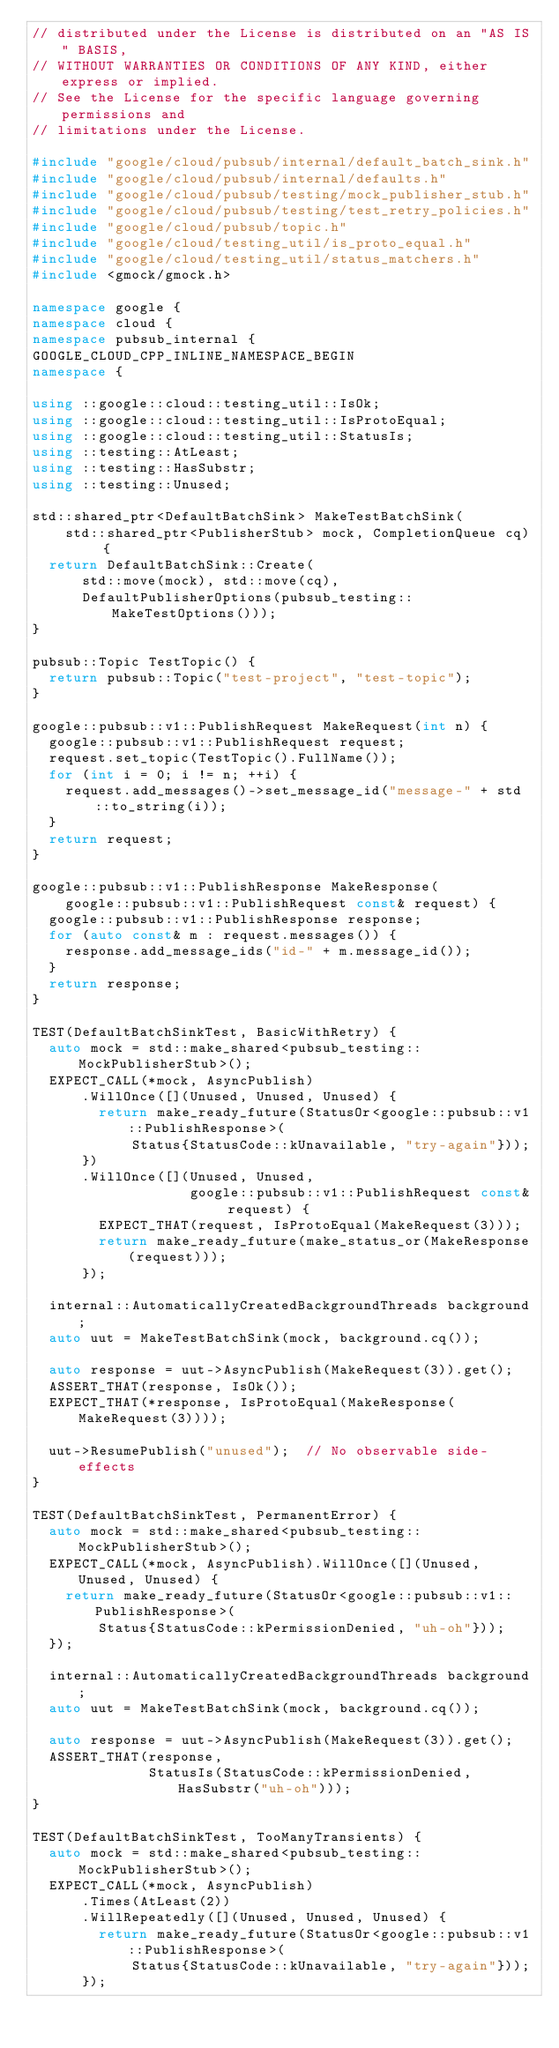<code> <loc_0><loc_0><loc_500><loc_500><_C++_>// distributed under the License is distributed on an "AS IS" BASIS,
// WITHOUT WARRANTIES OR CONDITIONS OF ANY KIND, either express or implied.
// See the License for the specific language governing permissions and
// limitations under the License.

#include "google/cloud/pubsub/internal/default_batch_sink.h"
#include "google/cloud/pubsub/internal/defaults.h"
#include "google/cloud/pubsub/testing/mock_publisher_stub.h"
#include "google/cloud/pubsub/testing/test_retry_policies.h"
#include "google/cloud/pubsub/topic.h"
#include "google/cloud/testing_util/is_proto_equal.h"
#include "google/cloud/testing_util/status_matchers.h"
#include <gmock/gmock.h>

namespace google {
namespace cloud {
namespace pubsub_internal {
GOOGLE_CLOUD_CPP_INLINE_NAMESPACE_BEGIN
namespace {

using ::google::cloud::testing_util::IsOk;
using ::google::cloud::testing_util::IsProtoEqual;
using ::google::cloud::testing_util::StatusIs;
using ::testing::AtLeast;
using ::testing::HasSubstr;
using ::testing::Unused;

std::shared_ptr<DefaultBatchSink> MakeTestBatchSink(
    std::shared_ptr<PublisherStub> mock, CompletionQueue cq) {
  return DefaultBatchSink::Create(
      std::move(mock), std::move(cq),
      DefaultPublisherOptions(pubsub_testing::MakeTestOptions()));
}

pubsub::Topic TestTopic() {
  return pubsub::Topic("test-project", "test-topic");
}

google::pubsub::v1::PublishRequest MakeRequest(int n) {
  google::pubsub::v1::PublishRequest request;
  request.set_topic(TestTopic().FullName());
  for (int i = 0; i != n; ++i) {
    request.add_messages()->set_message_id("message-" + std::to_string(i));
  }
  return request;
}

google::pubsub::v1::PublishResponse MakeResponse(
    google::pubsub::v1::PublishRequest const& request) {
  google::pubsub::v1::PublishResponse response;
  for (auto const& m : request.messages()) {
    response.add_message_ids("id-" + m.message_id());
  }
  return response;
}

TEST(DefaultBatchSinkTest, BasicWithRetry) {
  auto mock = std::make_shared<pubsub_testing::MockPublisherStub>();
  EXPECT_CALL(*mock, AsyncPublish)
      .WillOnce([](Unused, Unused, Unused) {
        return make_ready_future(StatusOr<google::pubsub::v1::PublishResponse>(
            Status{StatusCode::kUnavailable, "try-again"}));
      })
      .WillOnce([](Unused, Unused,
                   google::pubsub::v1::PublishRequest const& request) {
        EXPECT_THAT(request, IsProtoEqual(MakeRequest(3)));
        return make_ready_future(make_status_or(MakeResponse(request)));
      });

  internal::AutomaticallyCreatedBackgroundThreads background;
  auto uut = MakeTestBatchSink(mock, background.cq());

  auto response = uut->AsyncPublish(MakeRequest(3)).get();
  ASSERT_THAT(response, IsOk());
  EXPECT_THAT(*response, IsProtoEqual(MakeResponse(MakeRequest(3))));

  uut->ResumePublish("unused");  // No observable side-effects
}

TEST(DefaultBatchSinkTest, PermanentError) {
  auto mock = std::make_shared<pubsub_testing::MockPublisherStub>();
  EXPECT_CALL(*mock, AsyncPublish).WillOnce([](Unused, Unused, Unused) {
    return make_ready_future(StatusOr<google::pubsub::v1::PublishResponse>(
        Status{StatusCode::kPermissionDenied, "uh-oh"}));
  });

  internal::AutomaticallyCreatedBackgroundThreads background;
  auto uut = MakeTestBatchSink(mock, background.cq());

  auto response = uut->AsyncPublish(MakeRequest(3)).get();
  ASSERT_THAT(response,
              StatusIs(StatusCode::kPermissionDenied, HasSubstr("uh-oh")));
}

TEST(DefaultBatchSinkTest, TooManyTransients) {
  auto mock = std::make_shared<pubsub_testing::MockPublisherStub>();
  EXPECT_CALL(*mock, AsyncPublish)
      .Times(AtLeast(2))
      .WillRepeatedly([](Unused, Unused, Unused) {
        return make_ready_future(StatusOr<google::pubsub::v1::PublishResponse>(
            Status{StatusCode::kUnavailable, "try-again"}));
      });
</code> 